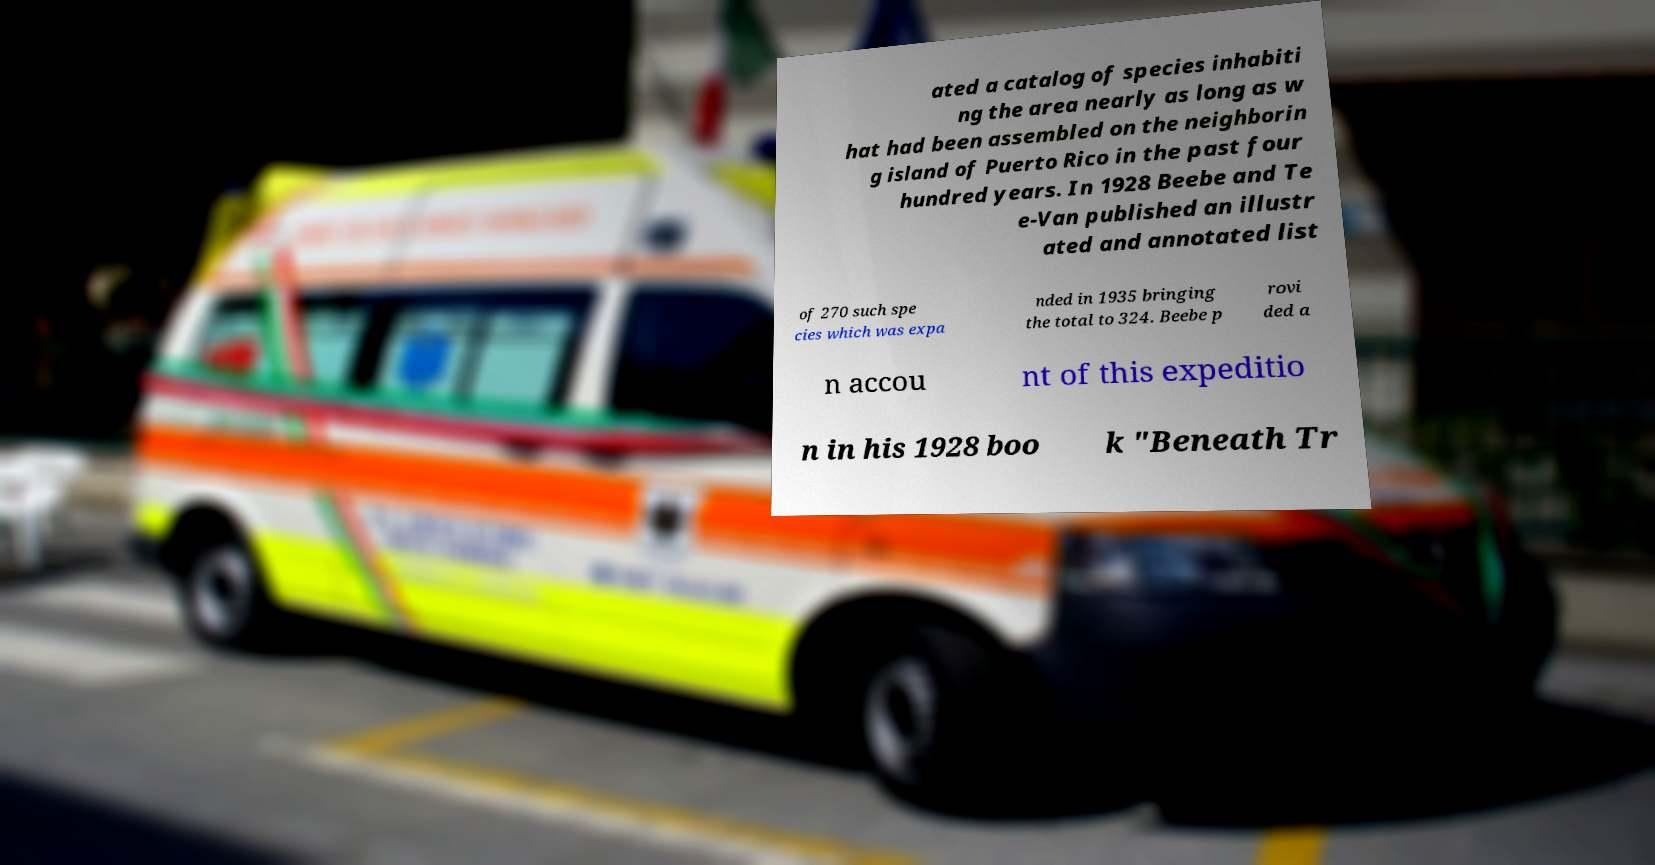Can you accurately transcribe the text from the provided image for me? ated a catalog of species inhabiti ng the area nearly as long as w hat had been assembled on the neighborin g island of Puerto Rico in the past four hundred years. In 1928 Beebe and Te e-Van published an illustr ated and annotated list of 270 such spe cies which was expa nded in 1935 bringing the total to 324. Beebe p rovi ded a n accou nt of this expeditio n in his 1928 boo k "Beneath Tr 